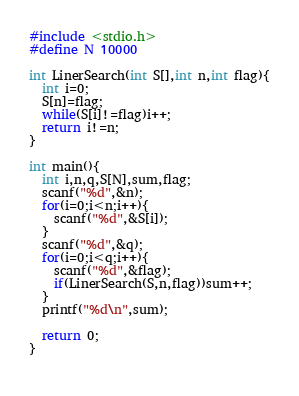Convert code to text. <code><loc_0><loc_0><loc_500><loc_500><_C_>#include <stdio.h>
#define N 10000

int LinerSearch(int S[],int n,int flag){
  int i=0;
  S[n]=flag;
  while(S[i]!=flag)i++;
  return i!=n;
}

int main(){
  int i,n,q,S[N],sum,flag;
  scanf("%d",&n);
  for(i=0;i<n;i++){
    scanf("%d",&S[i]);
  }
  scanf("%d",&q);
  for(i=0;i<q;i++){
    scanf("%d",&flag);
    if(LinerSearch(S,n,flag))sum++;
  }
  printf("%d\n",sum);

  return 0;
}
  

</code> 